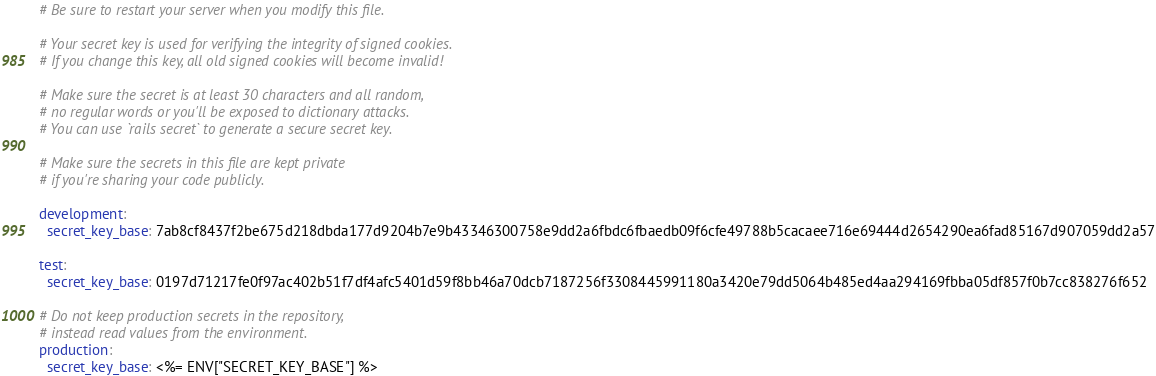<code> <loc_0><loc_0><loc_500><loc_500><_YAML_># Be sure to restart your server when you modify this file.

# Your secret key is used for verifying the integrity of signed cookies.
# If you change this key, all old signed cookies will become invalid!

# Make sure the secret is at least 30 characters and all random,
# no regular words or you'll be exposed to dictionary attacks.
# You can use `rails secret` to generate a secure secret key.

# Make sure the secrets in this file are kept private
# if you're sharing your code publicly.

development:
  secret_key_base: 7ab8cf8437f2be675d218dbda177d9204b7e9b43346300758e9dd2a6fbdc6fbaedb09f6cfe49788b5cacaee716e69444d2654290ea6fad85167d907059dd2a57

test:
  secret_key_base: 0197d71217fe0f97ac402b51f7df4afc5401d59f8bb46a70dcb7187256f3308445991180a3420e79dd5064b485ed4aa294169fbba05df857f0b7cc838276f652

# Do not keep production secrets in the repository,
# instead read values from the environment.
production:
  secret_key_base: <%= ENV["SECRET_KEY_BASE"] %>
</code> 